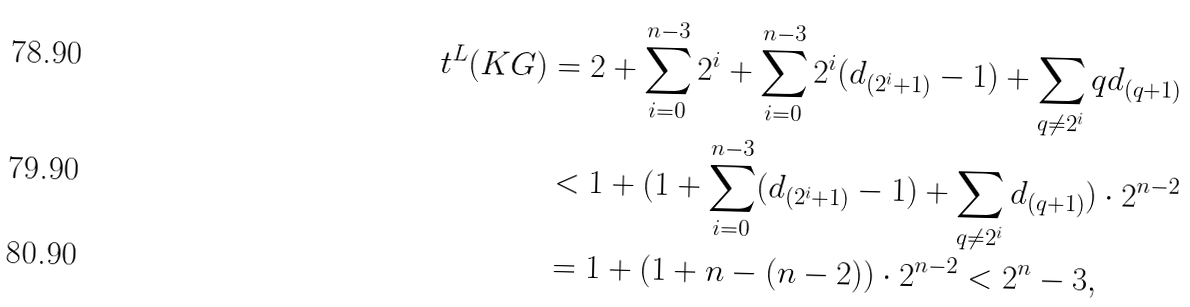Convert formula to latex. <formula><loc_0><loc_0><loc_500><loc_500>t ^ { L } ( K G ) & = 2 + \sum _ { i = 0 } ^ { n - 3 } { 2 ^ { i } } + \sum _ { i = 0 } ^ { n - 3 } { 2 ^ { i } } ( d _ { ( { 2 ^ { i } } + 1 ) } - 1 ) + \sum _ { q \not = 2 ^ { i } } q d _ { ( { q } + 1 ) } \\ & < 1 + ( 1 + \sum _ { i = 0 } ^ { n - 3 } ( d _ { ( { 2 ^ { i } } + 1 ) } - 1 ) + \sum _ { q \not = 2 ^ { i } } d _ { ( { q } + 1 ) } ) \cdot 2 ^ { n - 2 } \\ & = 1 + ( 1 + n - ( n - 2 ) ) \cdot 2 ^ { n - 2 } < 2 ^ { n } - 3 ,</formula> 